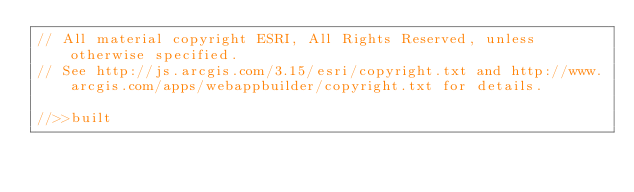<code> <loc_0><loc_0><loc_500><loc_500><_JavaScript_>// All material copyright ESRI, All Rights Reserved, unless otherwise specified.
// See http://js.arcgis.com/3.15/esri/copyright.txt and http://www.arcgis.com/apps/webappbuilder/copyright.txt for details.
//>>built</code> 